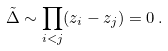<formula> <loc_0><loc_0><loc_500><loc_500>\tilde { \Delta } \sim \prod _ { i < j } ( z _ { i } - z _ { j } ) = 0 \, .</formula> 